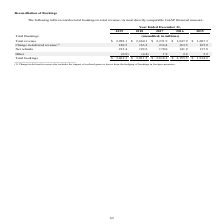From Godaddy's financial document, What financial items does reconciliation of total bookings consist of? The document contains multiple relevant values: Total revenue, Change in deferred revenue, Net refunds, Other. From the document: "Change in deferred revenue (1) 180.5 163.2 214.4 163.5 165.9 Net refunds 233.4 192.6 170.0 141.9 137.8 eferred revenue (1) 180.5 163.2 214.4 163.5 165..." Also, What is the total bookings for each financial year shown in the table, in chronological order? The document contains multiple relevant values: $1,914.2, $2,155.5, $2,618.2, $3,011.5, $3,401.2 (in millions). From the document: "1.9 2.2 3.2 Total bookings $ 3,401.2 $ 3,011.5 $ 2,618.2 $ 2,155.5 $ 1,914.2 .2 Total bookings $ 3,401.2 $ 3,011.5 $ 2,618.2 $ 2,155.5 $ 1,914.2 Other..." Also, What is the net refunds for each financial year shown in the table, in chronological order? The document contains multiple relevant values: 137.8, 141.9, 170.0, 192.6, 233.4 (in millions). From the document: "nue (1) 180.5 163.2 214.4 163.5 165.9 Net refunds 233.4 192.6 170.0 141.9 137.8 2 214.4 163.5 165.9 Net refunds 233.4 192.6 170.0 141.9 137.8 5 163.2 ..." Additionally, Which financial year listed has the highest total bookings? According to the financial document, 2019. The relevant text states: "Year Ended December 31, 2019 2018 2017 2016 2015..." Also, How many financial years had total bookings below $3,000 millions? Counting the relevant items in the document: 2017 ,  2016 ,  2015, I find 3 instances. The key data points involved are: 2015, 2016, 2017. Also, can you calculate: What is the average total revenue for 2018 and 2019? To answer this question, I need to perform calculations using the financial data. The calculation is: (2,988.1+2,660.1)/2, which equals 2824.1 (in millions). This is based on the information: "unaudited; in millions) Total revenue $ 2,988.1 $ 2,660.1 $ 2,231.9 $ 1,847.9 $ 1,607.3 ookings: (unaudited; in millions) Total revenue $ 2,988.1 $ 2,660.1 $ 2,231.9 $ 1,847.9 $ 1,607.3..." The key data points involved are: 2,660.1, 2,988.1. 